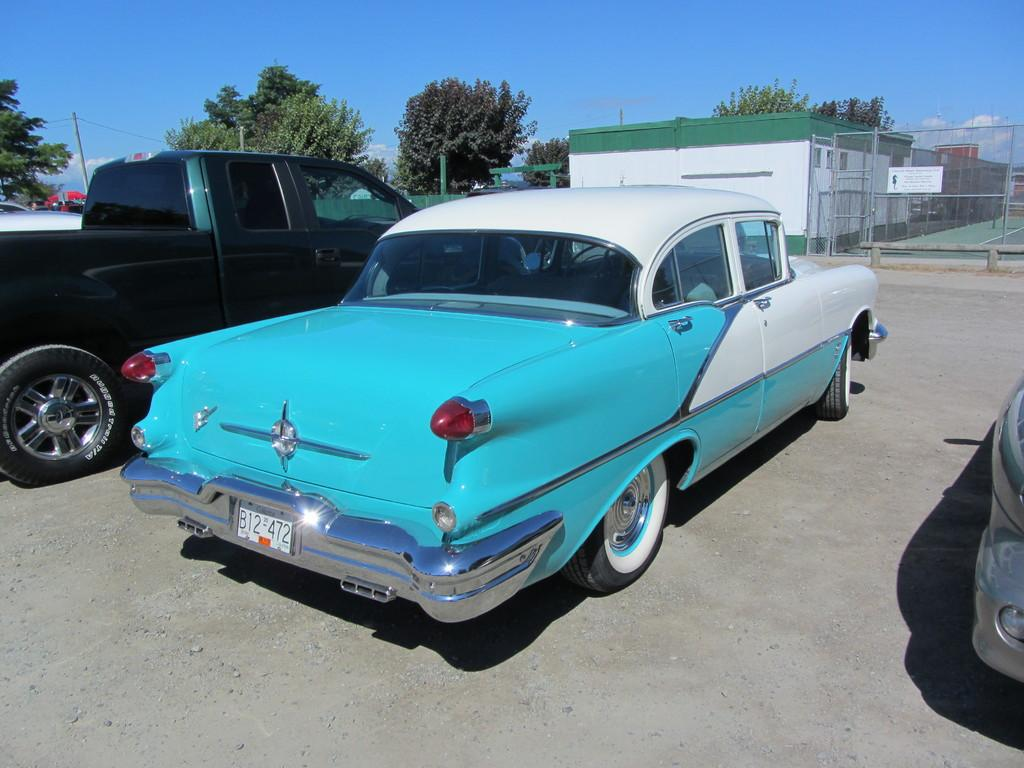What is happening on the road in the image? There are vehicles on the road in the image. What can be seen in the distance behind the vehicles? There are buildings, a fence, trees, poles with wires attached, and the sky visible in the background of the image. Can you see any quicksand on the road in the image? No, there is no quicksand present in the image. Is there a tramp performing tricks in the image? No, there is no tramp performing tricks in the image. 